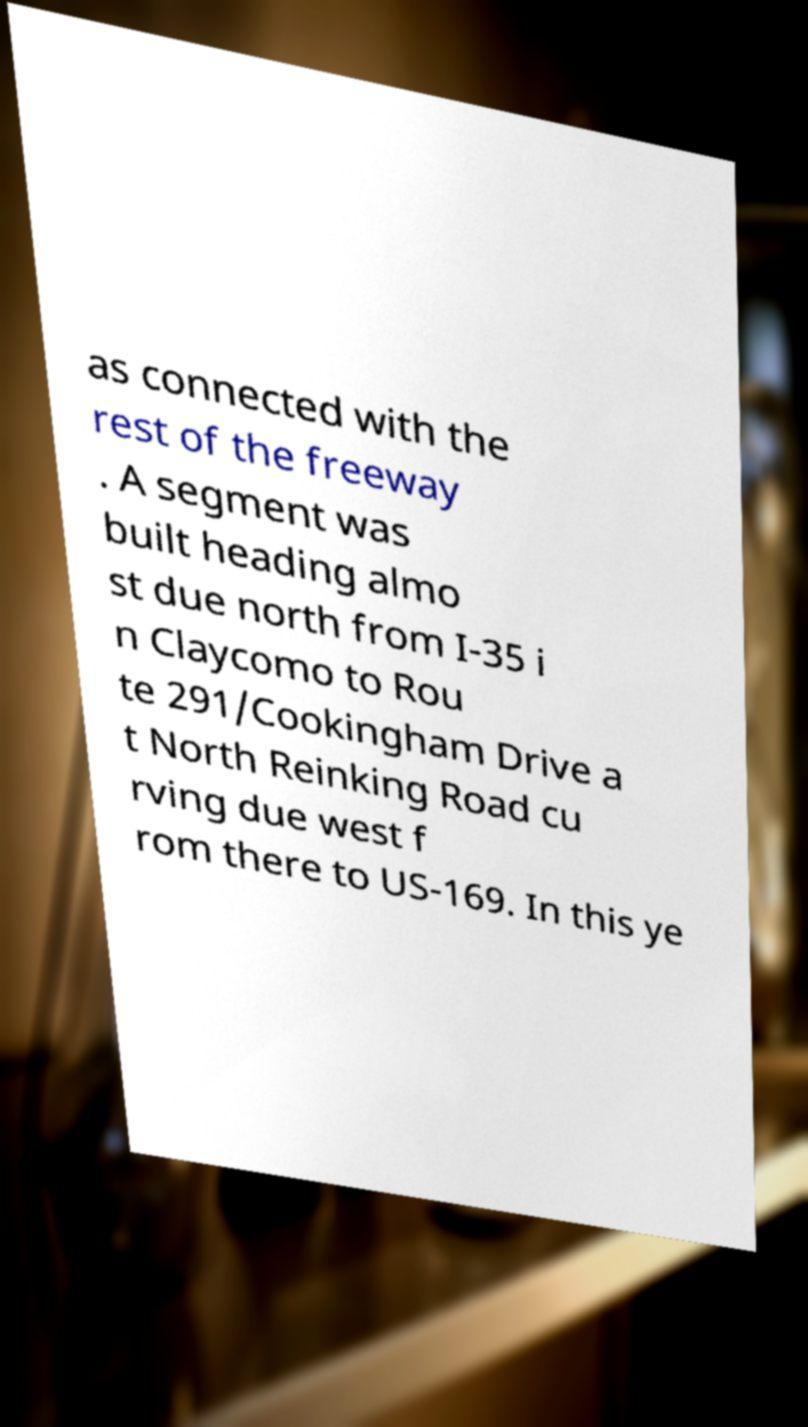Can you accurately transcribe the text from the provided image for me? as connected with the rest of the freeway . A segment was built heading almo st due north from I-35 i n Claycomo to Rou te 291/Cookingham Drive a t North Reinking Road cu rving due west f rom there to US-169. In this ye 